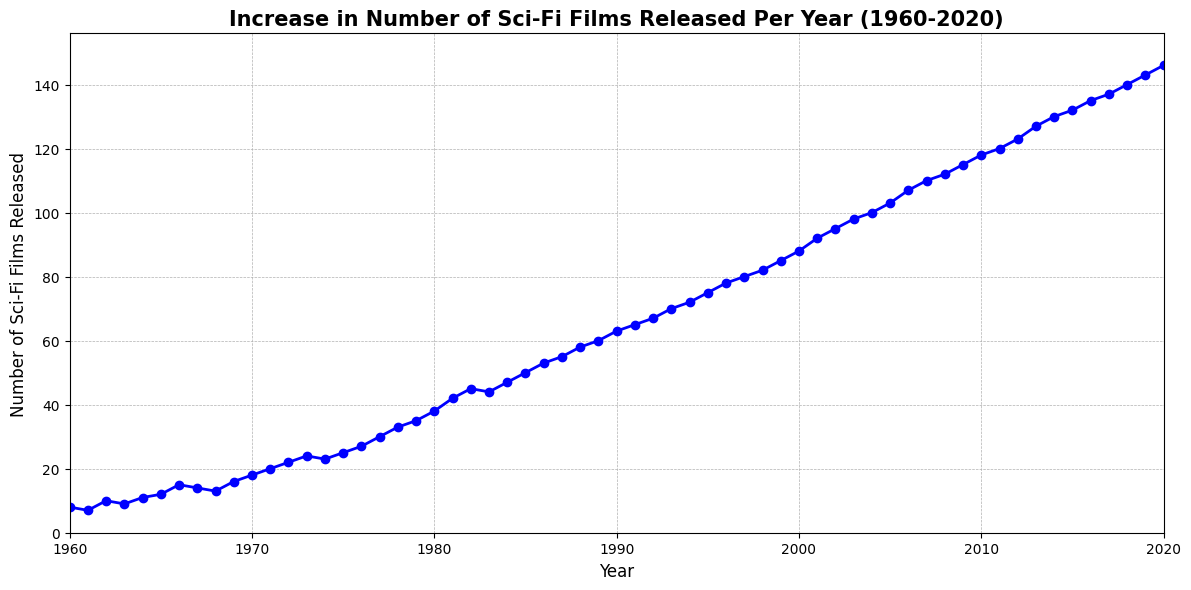what is the increase in the number of sci-fi films released from 1960 to 1970? To find the increase, subtract the number of films released in 1960 from the number of films released in 1970. The number in 1970 is 18 and in 1960 it's 8, so the increase is 18 - 8 = 10.
Answer: 10 In which year did the number of sci-fi films released first reach or exceed 50? Look at the y-axis values and find the first year where the number of films is 50 or more. In this case, it happens in 1985.
Answer: 1985 Between which consecutive years is the largest increase in the number of sci-fi films released? By examining the steepness of the line segments, the largest increase appears between 1981 and 1982, where the number increases from 42 to 45.
Answer: 1981-1982 What is the average number of sci-fi films released annually between 1990 and 2000? To calculate the average, sum the number of films released from 1990 to 2000 and divide by the number of years. Sum = 63+65+67+70+72+75+78+80+82+85+88 = 815, Number of years = 11, Average = 815 / 11 = 74.1
Answer: 74.1 Which decade saw the highest total increase in the number of sci-fi films released? Calculate the increase for each decade: 1960s: 16-8=8, 1970s: 35-18=17, 1980s: 60-35=25, 1990s: 85-63=22, 2000s: 118-88=30, 2010s: 146-120=26, thus the highest increase is in the 2000s.
Answer: 2000s How many more films were released in 2020 compared to 2000? Subtract the number of films in 2000 (88) from those in 2020 (146). So, 146 - 88 = 58.
Answer: 58 What is the slope of the line between 1965 and 1975? The slope is given by the change in the number of films divided by the change in years. For this period, the change in number of films is 25 - 12 = 13, and the change in years is 1975 - 1965 = 10. Thus, the slope is 13/10 = 1.3 films per year.
Answer: 1.3 Compare the number of sci-fi films released in 1980 and 1990. How much higher is the release in 1990? Subtract the number in 1980 from the number in 1990. So, 63 - 38 = 25.
Answer: 25 During which time frame did the number of sci-fi films released double from their original count in 1960? The number of films released in 1960 was 8. Find the year when this number doubled (which is 16). From the data, in 1969, the number of films released is 16.
Answer: 1960-1969 By what percentage did the number of sci-fi films released increase from 2000 to 2020? To calculate the percentage increase, use the formula: ((new value - original value) / original value) * 100. Here it’s ((146 - 88) / 88) * 100 = 65.9%.
Answer: 65.9 